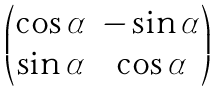<formula> <loc_0><loc_0><loc_500><loc_500>\begin{pmatrix} \cos \alpha & - \sin \alpha \\ \sin \alpha & \cos \alpha \end{pmatrix}</formula> 